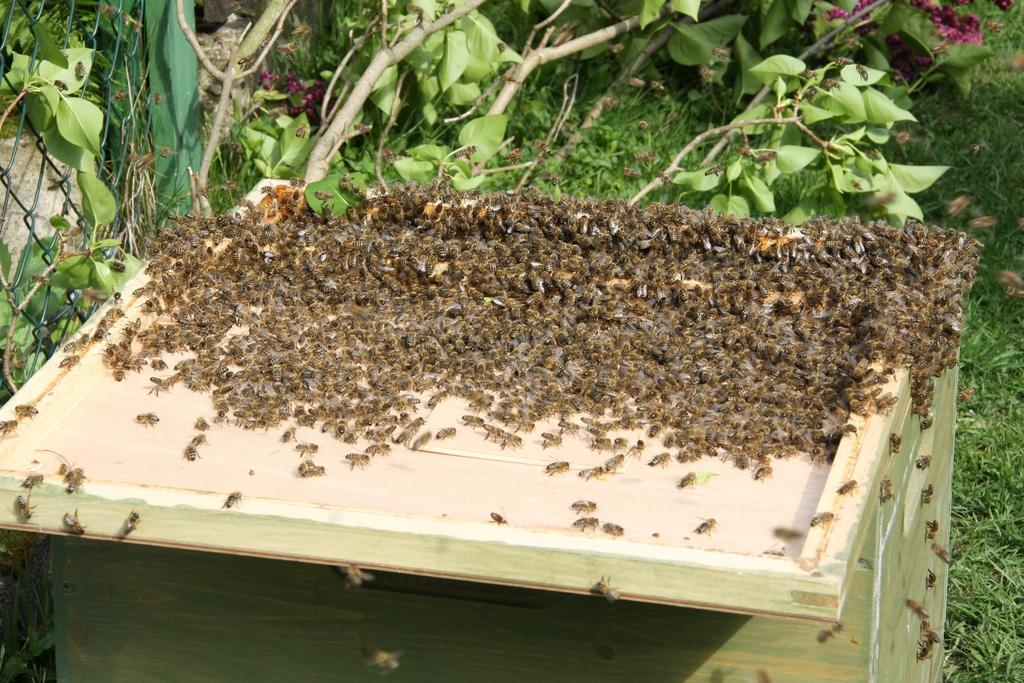What insects can be seen on the wooden table in the image? There are honey bees on a wooden table in the image. What can be seen in the background of the image? There is a fence, grass, and trees in the background of the image. What type of gold discovery can be seen in the image? There is no gold discovery present in the image; it features honey bees on a wooden table and a background with a fence, grass, and trees. 